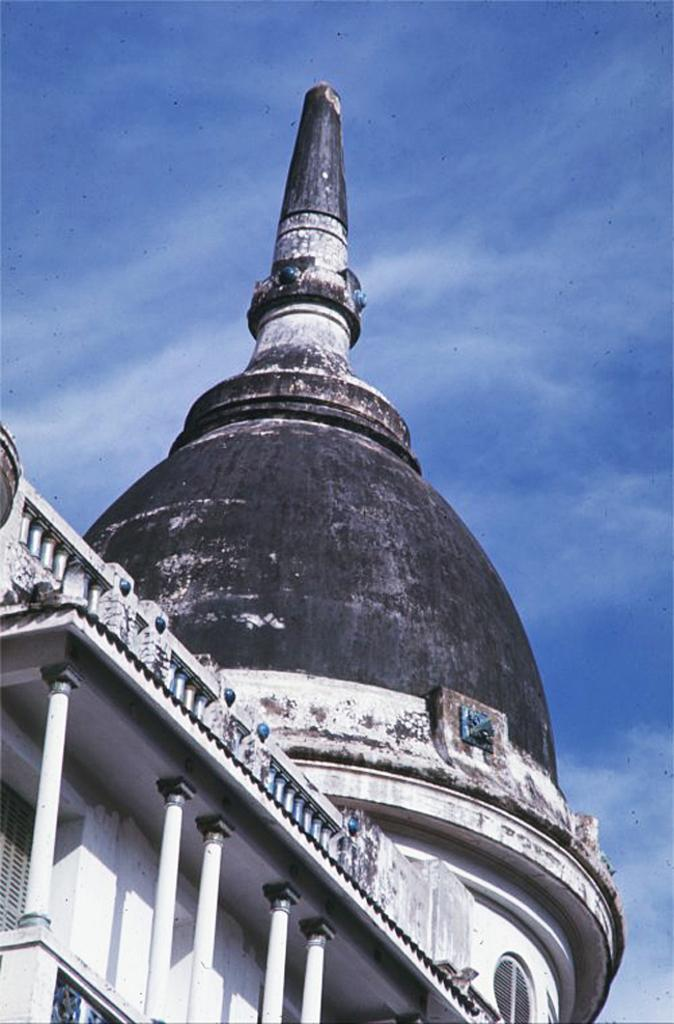What structure is present in the image? There is a building in the image. What part of the natural environment is visible in the image? The sky is visible in the background of the image. What type of birthday celebration is taking place in the image? There is no indication of a birthday celebration in the image; it only features a building and the sky. What time of day is it in the image? The time of day cannot be determined from the image, as it only features a building and the sky. 